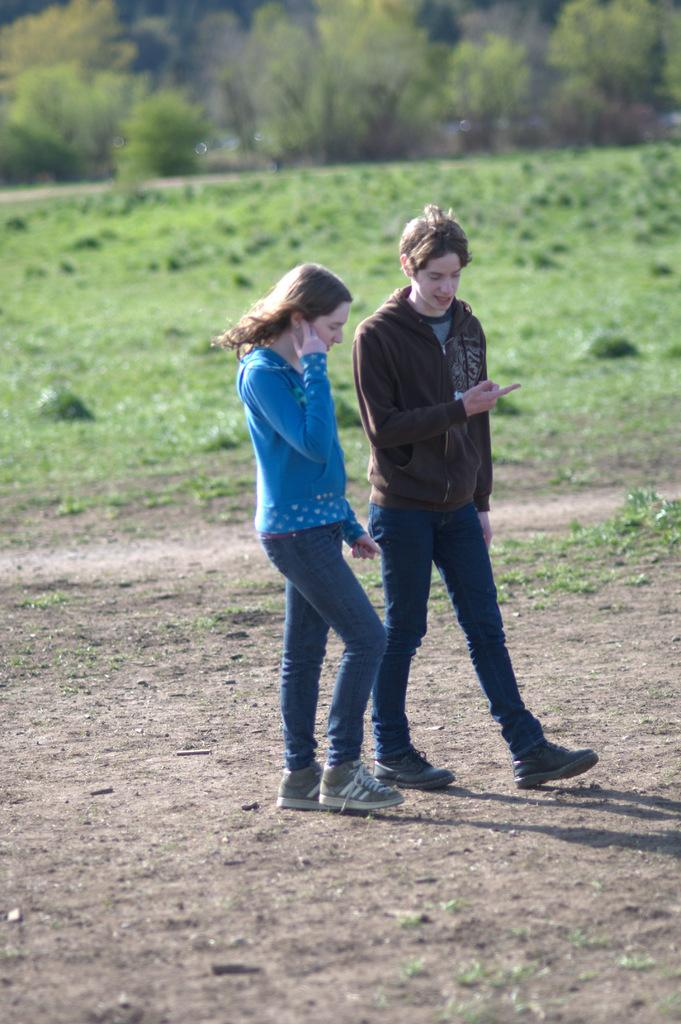Who are the two people in the center of the image? There is a lady and a man in the center of the image. What are the lady and the man doing in the image? The lady and the man are walking on the ground. What type of vegetation can be seen in the background of the image? Grass is present in the background of the image. What other natural elements are visible in the image? Trees are visible at the top of the image. What type of stamp can be seen on the lady's forehead in the image? There is no stamp present on the lady's forehead or anywhere else in the image. How many pages of the book can be seen in the image? There is no book or pages visible in the image. 